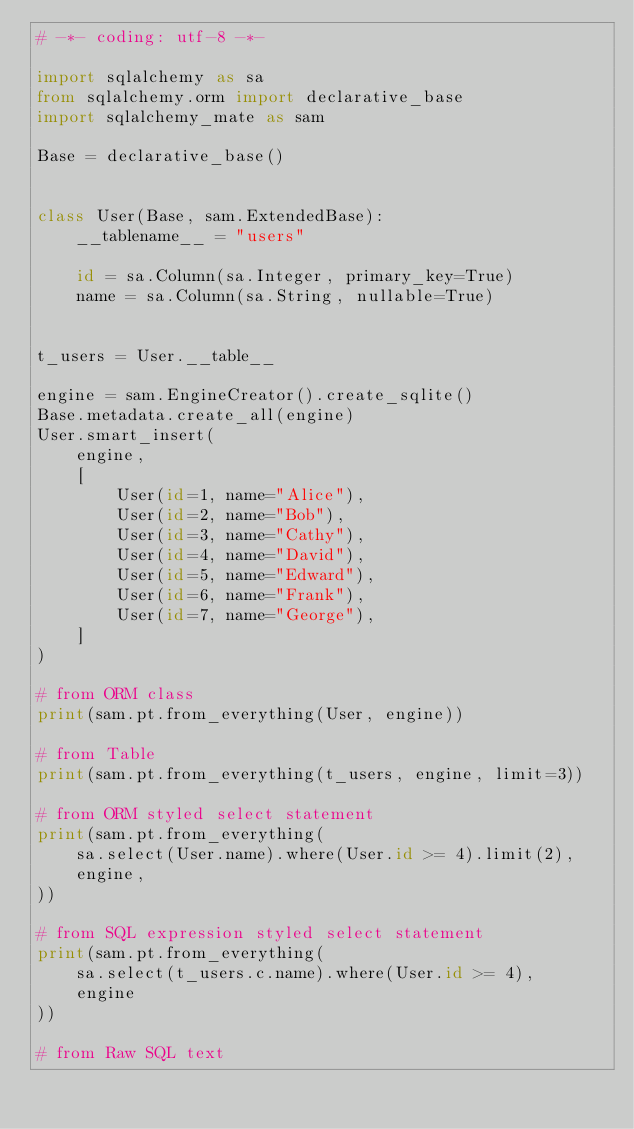Convert code to text. <code><loc_0><loc_0><loc_500><loc_500><_Python_># -*- coding: utf-8 -*-

import sqlalchemy as sa
from sqlalchemy.orm import declarative_base
import sqlalchemy_mate as sam

Base = declarative_base()


class User(Base, sam.ExtendedBase):
    __tablename__ = "users"

    id = sa.Column(sa.Integer, primary_key=True)
    name = sa.Column(sa.String, nullable=True)


t_users = User.__table__

engine = sam.EngineCreator().create_sqlite()
Base.metadata.create_all(engine)
User.smart_insert(
    engine,
    [
        User(id=1, name="Alice"),
        User(id=2, name="Bob"),
        User(id=3, name="Cathy"),
        User(id=4, name="David"),
        User(id=5, name="Edward"),
        User(id=6, name="Frank"),
        User(id=7, name="George"),
    ]
)

# from ORM class
print(sam.pt.from_everything(User, engine))

# from Table
print(sam.pt.from_everything(t_users, engine, limit=3))

# from ORM styled select statement
print(sam.pt.from_everything(
    sa.select(User.name).where(User.id >= 4).limit(2),
    engine,
))

# from SQL expression styled select statement
print(sam.pt.from_everything(
    sa.select(t_users.c.name).where(User.id >= 4),
    engine
))

# from Raw SQL text</code> 